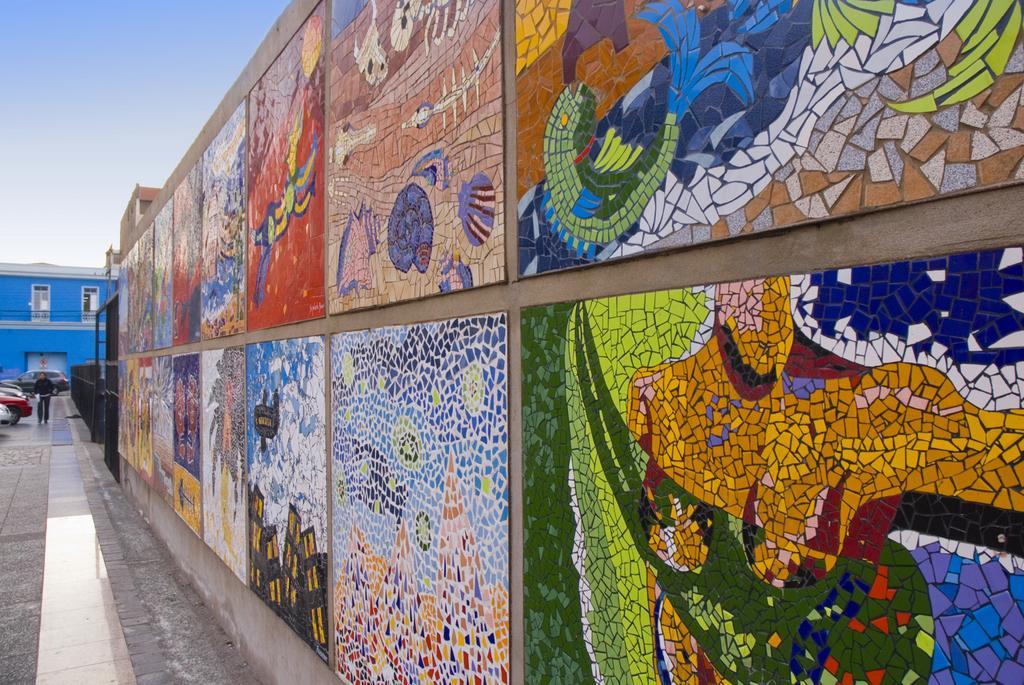Describe this image in one or two sentences. This picture is clicked outside. On the left we can see the group of vehicles seems to be parked on the ground and there is a person seems to be walking on the ground. On the right we can see the pictures of some objects on the wall. In the background there is a sky and a blue color building. 